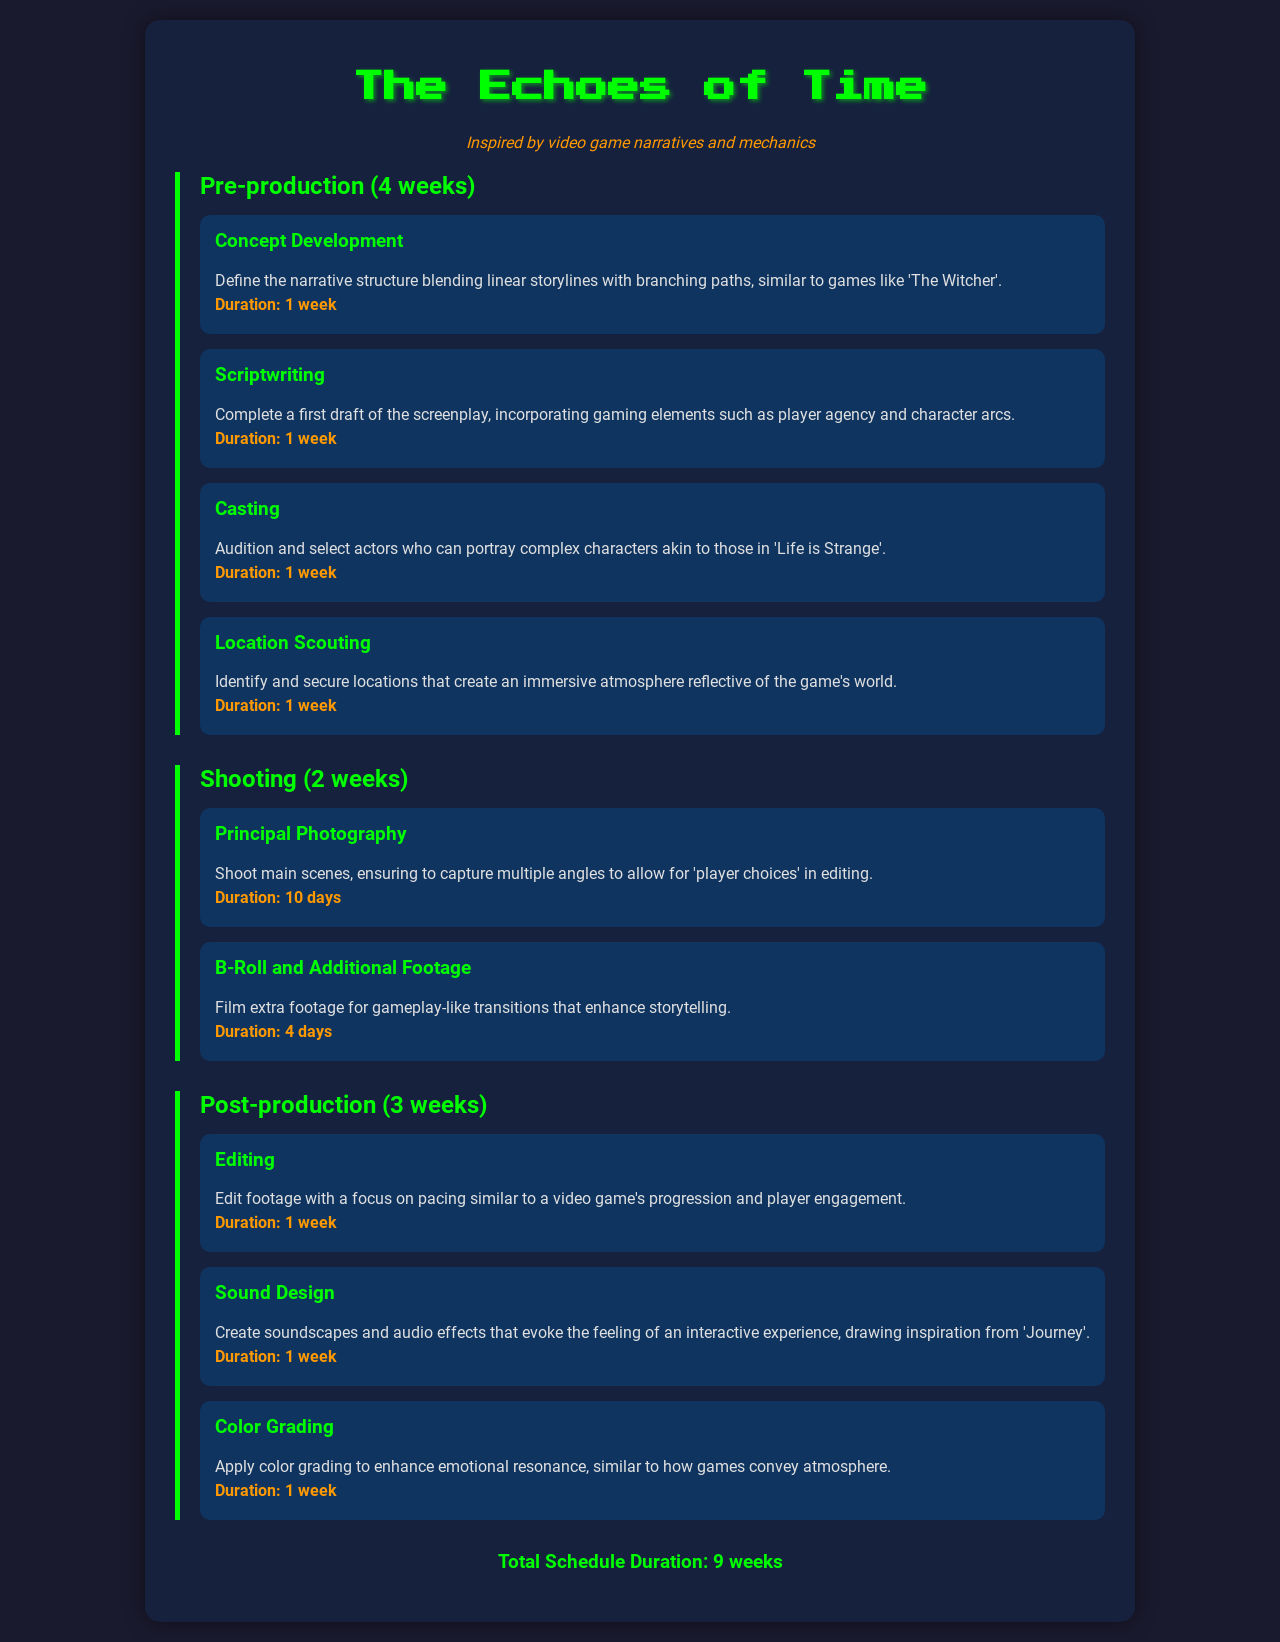What is the title of the film project? The title of the film project is stated clearly at the top of the document.
Answer: The Echoes of Time How long is the pre-production phase? The duration of the pre-production phase is specified in the section header.
Answer: 4 weeks What task takes 10 days to complete? The specific task duration in the shooting phase is highlighted in the task description.
Answer: Principal Photography What is the total schedule duration for the project? The total schedule duration is summarized at the end of the document.
Answer: 9 weeks Which video game is referenced in the scriptwriting task? The document mentions a specific game to illustrate the elements of the screenplay.
Answer: The Witcher How many tasks are listed in the post-production phase? The number of tasks in the post-production section indicates the scope of that phase.
Answer: 3 tasks Which task focuses on audio effects? The task related to sound is described in the post-production section of the document.
Answer: Sound Design What type of filming includes capturing multiple angles? The description in the shooting section explains this type of filming.
Answer: Principal Photography What video game is mentioned in relation to creating immersive soundscapes? The specific game referenced for inspiration in sound design is noted in the relevant task.
Answer: Journey 